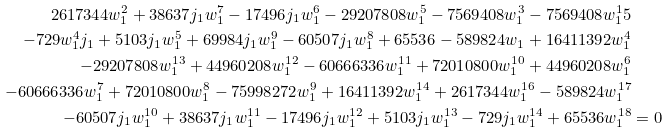<formula> <loc_0><loc_0><loc_500><loc_500>2 6 1 7 3 4 4 w _ { 1 } ^ { 2 } + 3 8 6 3 7 j _ { 1 } w _ { 1 } ^ { 7 } - 1 7 4 9 6 j _ { 1 } w _ { 1 } ^ { 6 } - 2 9 2 0 7 8 0 8 w _ { 1 } ^ { 5 } - 7 5 6 9 4 0 8 w _ { 1 } ^ { 3 } - 7 5 6 9 4 0 8 w _ { 1 } ^ { 1 } 5 \\ - 7 2 9 w _ { 1 } ^ { 4 } j _ { 1 } + 5 1 0 3 j _ { 1 } w _ { 1 } ^ { 5 } + 6 9 9 8 4 j _ { 1 } w _ { 1 } ^ { 9 } - 6 0 5 0 7 j _ { 1 } w _ { 1 } ^ { 8 } + 6 5 5 3 6 - 5 8 9 8 2 4 w _ { 1 } + 1 6 4 1 1 3 9 2 w _ { 1 } ^ { 4 } \\ - 2 9 2 0 7 8 0 8 w _ { 1 } ^ { 1 3 } + 4 4 9 6 0 2 0 8 w _ { 1 } ^ { 1 2 } - 6 0 6 6 6 3 3 6 w _ { 1 } ^ { 1 1 } + 7 2 0 1 0 8 0 0 w _ { 1 } ^ { 1 0 } + 4 4 9 6 0 2 0 8 w _ { 1 } ^ { 6 } \\ - 6 0 6 6 6 3 3 6 w _ { 1 } ^ { 7 } + 7 2 0 1 0 8 0 0 w _ { 1 } ^ { 8 } - 7 5 9 9 8 2 7 2 w _ { 1 } ^ { 9 } + 1 6 4 1 1 3 9 2 w _ { 1 } ^ { 1 4 } + 2 6 1 7 3 4 4 w _ { 1 } ^ { 1 6 } - 5 8 9 8 2 4 w _ { 1 } ^ { 1 7 } \\ - 6 0 5 0 7 j _ { 1 } w _ { 1 } ^ { 1 0 } + 3 8 6 3 7 j _ { 1 } w _ { 1 } ^ { 1 1 } - 1 7 4 9 6 j _ { 1 } w _ { 1 } ^ { 1 2 } + 5 1 0 3 j _ { 1 } w _ { 1 } ^ { 1 3 } - 7 2 9 j _ { 1 } w _ { 1 } ^ { 1 4 } + 6 5 5 3 6 w _ { 1 } ^ { 1 8 } & = 0</formula> 